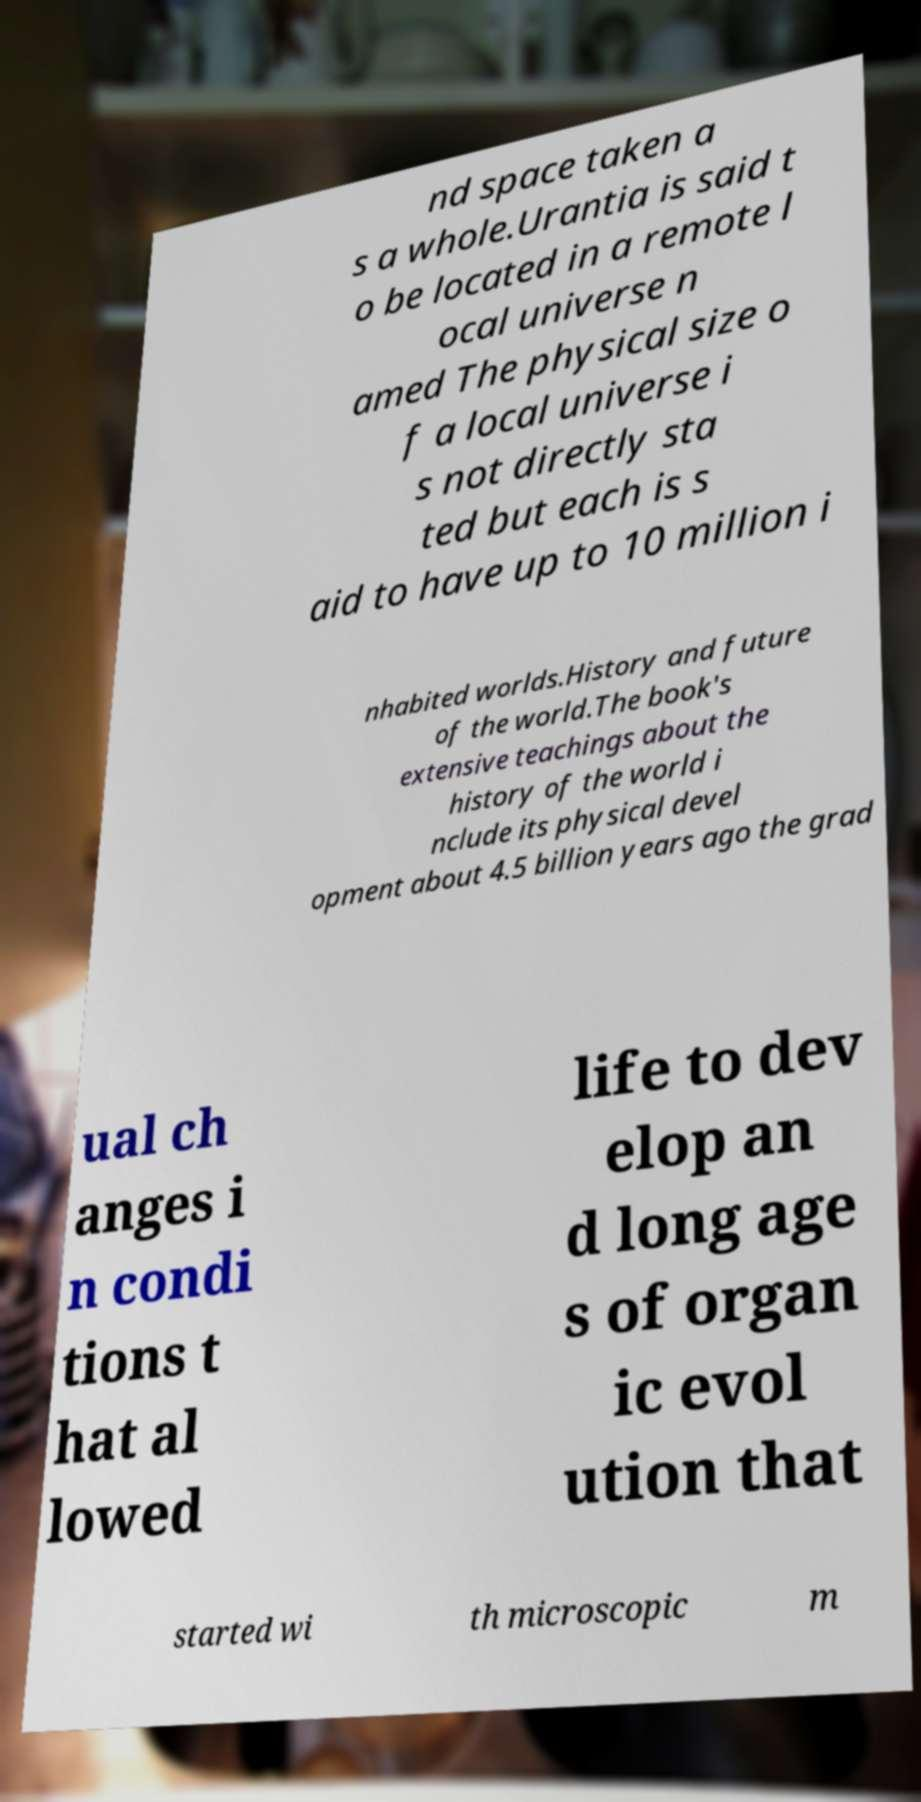Could you assist in decoding the text presented in this image and type it out clearly? nd space taken a s a whole.Urantia is said t o be located in a remote l ocal universe n amed The physical size o f a local universe i s not directly sta ted but each is s aid to have up to 10 million i nhabited worlds.History and future of the world.The book's extensive teachings about the history of the world i nclude its physical devel opment about 4.5 billion years ago the grad ual ch anges i n condi tions t hat al lowed life to dev elop an d long age s of organ ic evol ution that started wi th microscopic m 